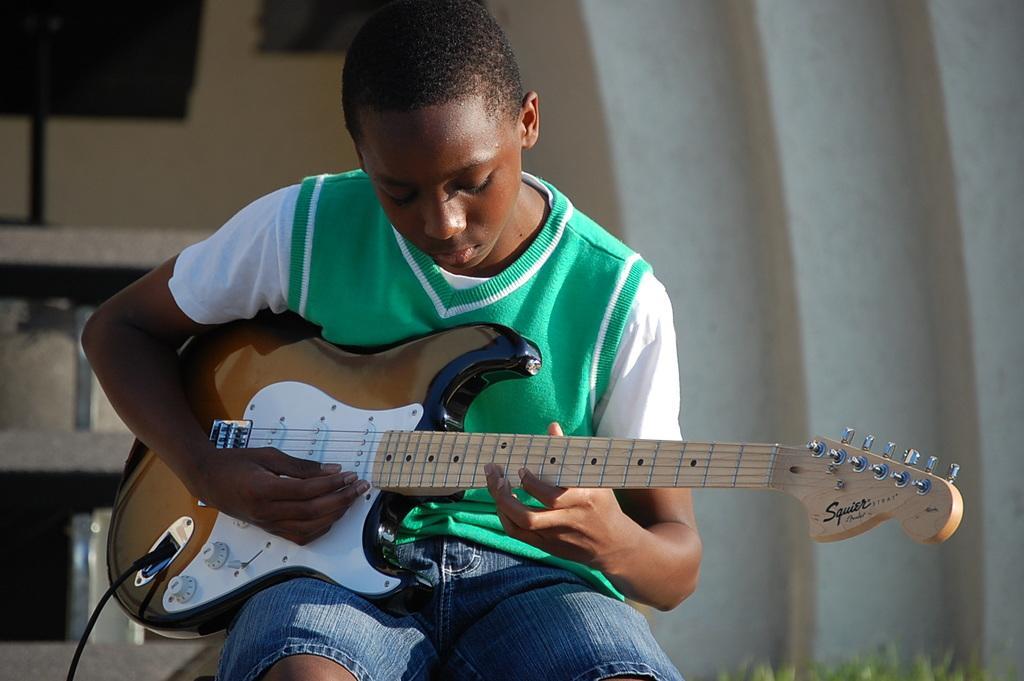Describe this image in one or two sentences. In this image i can see a boy sitting and holding a guitar. 